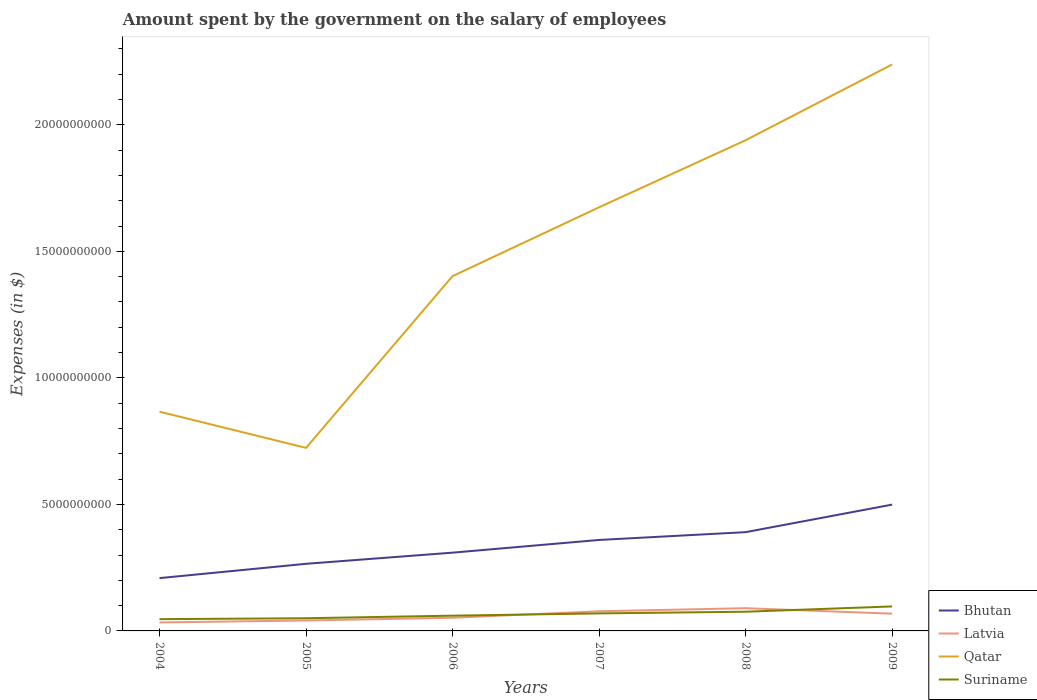Does the line corresponding to Bhutan intersect with the line corresponding to Latvia?
Offer a terse response. No. Is the number of lines equal to the number of legend labels?
Keep it short and to the point. Yes. Across all years, what is the maximum amount spent on the salary of employees by the government in Qatar?
Keep it short and to the point. 7.23e+09. In which year was the amount spent on the salary of employees by the government in Qatar maximum?
Provide a short and direct response. 2005. What is the total amount spent on the salary of employees by the government in Qatar in the graph?
Offer a very short reply. -6.79e+09. What is the difference between the highest and the second highest amount spent on the salary of employees by the government in Bhutan?
Ensure brevity in your answer.  2.90e+09. What is the difference between the highest and the lowest amount spent on the salary of employees by the government in Suriname?
Offer a very short reply. 3. What is the difference between two consecutive major ticks on the Y-axis?
Give a very brief answer. 5.00e+09. Are the values on the major ticks of Y-axis written in scientific E-notation?
Give a very brief answer. No. Does the graph contain grids?
Provide a short and direct response. No. Where does the legend appear in the graph?
Offer a terse response. Bottom right. How many legend labels are there?
Your answer should be very brief. 4. How are the legend labels stacked?
Provide a short and direct response. Vertical. What is the title of the graph?
Ensure brevity in your answer.  Amount spent by the government on the salary of employees. Does "Iceland" appear as one of the legend labels in the graph?
Offer a terse response. No. What is the label or title of the Y-axis?
Offer a very short reply. Expenses (in $). What is the Expenses (in $) of Bhutan in 2004?
Keep it short and to the point. 2.09e+09. What is the Expenses (in $) in Latvia in 2004?
Provide a succinct answer. 3.35e+08. What is the Expenses (in $) of Qatar in 2004?
Give a very brief answer. 8.66e+09. What is the Expenses (in $) of Suriname in 2004?
Ensure brevity in your answer.  4.65e+08. What is the Expenses (in $) of Bhutan in 2005?
Make the answer very short. 2.65e+09. What is the Expenses (in $) in Latvia in 2005?
Provide a short and direct response. 4.13e+08. What is the Expenses (in $) of Qatar in 2005?
Offer a very short reply. 7.23e+09. What is the Expenses (in $) of Suriname in 2005?
Make the answer very short. 5.02e+08. What is the Expenses (in $) of Bhutan in 2006?
Keep it short and to the point. 3.09e+09. What is the Expenses (in $) of Latvia in 2006?
Ensure brevity in your answer.  5.21e+08. What is the Expenses (in $) of Qatar in 2006?
Make the answer very short. 1.40e+1. What is the Expenses (in $) of Suriname in 2006?
Your response must be concise. 6.03e+08. What is the Expenses (in $) of Bhutan in 2007?
Your answer should be very brief. 3.60e+09. What is the Expenses (in $) in Latvia in 2007?
Your answer should be compact. 7.76e+08. What is the Expenses (in $) of Qatar in 2007?
Your answer should be very brief. 1.67e+1. What is the Expenses (in $) of Suriname in 2007?
Your response must be concise. 6.92e+08. What is the Expenses (in $) in Bhutan in 2008?
Your response must be concise. 3.90e+09. What is the Expenses (in $) of Latvia in 2008?
Your answer should be compact. 8.98e+08. What is the Expenses (in $) in Qatar in 2008?
Provide a succinct answer. 1.94e+1. What is the Expenses (in $) in Suriname in 2008?
Offer a very short reply. 7.59e+08. What is the Expenses (in $) in Bhutan in 2009?
Provide a short and direct response. 4.99e+09. What is the Expenses (in $) in Latvia in 2009?
Your answer should be compact. 6.81e+08. What is the Expenses (in $) of Qatar in 2009?
Offer a terse response. 2.24e+1. What is the Expenses (in $) of Suriname in 2009?
Give a very brief answer. 9.68e+08. Across all years, what is the maximum Expenses (in $) of Bhutan?
Provide a short and direct response. 4.99e+09. Across all years, what is the maximum Expenses (in $) in Latvia?
Give a very brief answer. 8.98e+08. Across all years, what is the maximum Expenses (in $) of Qatar?
Offer a very short reply. 2.24e+1. Across all years, what is the maximum Expenses (in $) of Suriname?
Offer a terse response. 9.68e+08. Across all years, what is the minimum Expenses (in $) of Bhutan?
Give a very brief answer. 2.09e+09. Across all years, what is the minimum Expenses (in $) of Latvia?
Keep it short and to the point. 3.35e+08. Across all years, what is the minimum Expenses (in $) in Qatar?
Offer a terse response. 7.23e+09. Across all years, what is the minimum Expenses (in $) of Suriname?
Ensure brevity in your answer.  4.65e+08. What is the total Expenses (in $) of Bhutan in the graph?
Offer a terse response. 2.03e+1. What is the total Expenses (in $) of Latvia in the graph?
Make the answer very short. 3.63e+09. What is the total Expenses (in $) in Qatar in the graph?
Your response must be concise. 8.84e+1. What is the total Expenses (in $) of Suriname in the graph?
Provide a succinct answer. 3.99e+09. What is the difference between the Expenses (in $) in Bhutan in 2004 and that in 2005?
Provide a short and direct response. -5.66e+08. What is the difference between the Expenses (in $) of Latvia in 2004 and that in 2005?
Ensure brevity in your answer.  -7.79e+07. What is the difference between the Expenses (in $) in Qatar in 2004 and that in 2005?
Offer a very short reply. 1.43e+09. What is the difference between the Expenses (in $) of Suriname in 2004 and that in 2005?
Your response must be concise. -3.64e+07. What is the difference between the Expenses (in $) of Bhutan in 2004 and that in 2006?
Your answer should be compact. -1.01e+09. What is the difference between the Expenses (in $) of Latvia in 2004 and that in 2006?
Make the answer very short. -1.86e+08. What is the difference between the Expenses (in $) of Qatar in 2004 and that in 2006?
Provide a succinct answer. -5.36e+09. What is the difference between the Expenses (in $) in Suriname in 2004 and that in 2006?
Your answer should be compact. -1.38e+08. What is the difference between the Expenses (in $) in Bhutan in 2004 and that in 2007?
Your answer should be compact. -1.51e+09. What is the difference between the Expenses (in $) in Latvia in 2004 and that in 2007?
Provide a succinct answer. -4.41e+08. What is the difference between the Expenses (in $) of Qatar in 2004 and that in 2007?
Provide a short and direct response. -8.08e+09. What is the difference between the Expenses (in $) in Suriname in 2004 and that in 2007?
Your response must be concise. -2.27e+08. What is the difference between the Expenses (in $) of Bhutan in 2004 and that in 2008?
Keep it short and to the point. -1.82e+09. What is the difference between the Expenses (in $) of Latvia in 2004 and that in 2008?
Make the answer very short. -5.63e+08. What is the difference between the Expenses (in $) in Qatar in 2004 and that in 2008?
Offer a very short reply. -1.07e+1. What is the difference between the Expenses (in $) in Suriname in 2004 and that in 2008?
Keep it short and to the point. -2.93e+08. What is the difference between the Expenses (in $) of Bhutan in 2004 and that in 2009?
Offer a terse response. -2.90e+09. What is the difference between the Expenses (in $) in Latvia in 2004 and that in 2009?
Offer a terse response. -3.46e+08. What is the difference between the Expenses (in $) in Qatar in 2004 and that in 2009?
Your answer should be compact. -1.37e+1. What is the difference between the Expenses (in $) of Suriname in 2004 and that in 2009?
Offer a very short reply. -5.02e+08. What is the difference between the Expenses (in $) in Bhutan in 2005 and that in 2006?
Provide a short and direct response. -4.40e+08. What is the difference between the Expenses (in $) of Latvia in 2005 and that in 2006?
Your response must be concise. -1.08e+08. What is the difference between the Expenses (in $) of Qatar in 2005 and that in 2006?
Your response must be concise. -6.79e+09. What is the difference between the Expenses (in $) of Suriname in 2005 and that in 2006?
Your answer should be compact. -1.01e+08. What is the difference between the Expenses (in $) in Bhutan in 2005 and that in 2007?
Your response must be concise. -9.43e+08. What is the difference between the Expenses (in $) of Latvia in 2005 and that in 2007?
Offer a very short reply. -3.63e+08. What is the difference between the Expenses (in $) of Qatar in 2005 and that in 2007?
Your answer should be compact. -9.51e+09. What is the difference between the Expenses (in $) in Suriname in 2005 and that in 2007?
Keep it short and to the point. -1.91e+08. What is the difference between the Expenses (in $) in Bhutan in 2005 and that in 2008?
Offer a terse response. -1.25e+09. What is the difference between the Expenses (in $) of Latvia in 2005 and that in 2008?
Give a very brief answer. -4.85e+08. What is the difference between the Expenses (in $) in Qatar in 2005 and that in 2008?
Offer a terse response. -1.22e+1. What is the difference between the Expenses (in $) of Suriname in 2005 and that in 2008?
Keep it short and to the point. -2.57e+08. What is the difference between the Expenses (in $) of Bhutan in 2005 and that in 2009?
Provide a short and direct response. -2.34e+09. What is the difference between the Expenses (in $) of Latvia in 2005 and that in 2009?
Keep it short and to the point. -2.68e+08. What is the difference between the Expenses (in $) in Qatar in 2005 and that in 2009?
Your answer should be compact. -1.52e+1. What is the difference between the Expenses (in $) in Suriname in 2005 and that in 2009?
Offer a terse response. -4.66e+08. What is the difference between the Expenses (in $) of Bhutan in 2006 and that in 2007?
Your response must be concise. -5.02e+08. What is the difference between the Expenses (in $) of Latvia in 2006 and that in 2007?
Offer a very short reply. -2.56e+08. What is the difference between the Expenses (in $) of Qatar in 2006 and that in 2007?
Your answer should be compact. -2.72e+09. What is the difference between the Expenses (in $) in Suriname in 2006 and that in 2007?
Ensure brevity in your answer.  -8.94e+07. What is the difference between the Expenses (in $) of Bhutan in 2006 and that in 2008?
Keep it short and to the point. -8.10e+08. What is the difference between the Expenses (in $) of Latvia in 2006 and that in 2008?
Ensure brevity in your answer.  -3.77e+08. What is the difference between the Expenses (in $) of Qatar in 2006 and that in 2008?
Offer a terse response. -5.37e+09. What is the difference between the Expenses (in $) of Suriname in 2006 and that in 2008?
Make the answer very short. -1.56e+08. What is the difference between the Expenses (in $) of Bhutan in 2006 and that in 2009?
Provide a succinct answer. -1.90e+09. What is the difference between the Expenses (in $) of Latvia in 2006 and that in 2009?
Your answer should be compact. -1.60e+08. What is the difference between the Expenses (in $) in Qatar in 2006 and that in 2009?
Your answer should be very brief. -8.36e+09. What is the difference between the Expenses (in $) in Suriname in 2006 and that in 2009?
Offer a very short reply. -3.65e+08. What is the difference between the Expenses (in $) of Bhutan in 2007 and that in 2008?
Offer a very short reply. -3.08e+08. What is the difference between the Expenses (in $) in Latvia in 2007 and that in 2008?
Your response must be concise. -1.22e+08. What is the difference between the Expenses (in $) in Qatar in 2007 and that in 2008?
Your response must be concise. -2.65e+09. What is the difference between the Expenses (in $) of Suriname in 2007 and that in 2008?
Provide a succinct answer. -6.61e+07. What is the difference between the Expenses (in $) in Bhutan in 2007 and that in 2009?
Make the answer very short. -1.40e+09. What is the difference between the Expenses (in $) in Latvia in 2007 and that in 2009?
Give a very brief answer. 9.54e+07. What is the difference between the Expenses (in $) of Qatar in 2007 and that in 2009?
Make the answer very short. -5.64e+09. What is the difference between the Expenses (in $) of Suriname in 2007 and that in 2009?
Your response must be concise. -2.75e+08. What is the difference between the Expenses (in $) of Bhutan in 2008 and that in 2009?
Your answer should be compact. -1.09e+09. What is the difference between the Expenses (in $) in Latvia in 2008 and that in 2009?
Keep it short and to the point. 2.17e+08. What is the difference between the Expenses (in $) in Qatar in 2008 and that in 2009?
Keep it short and to the point. -2.99e+09. What is the difference between the Expenses (in $) of Suriname in 2008 and that in 2009?
Your answer should be very brief. -2.09e+08. What is the difference between the Expenses (in $) of Bhutan in 2004 and the Expenses (in $) of Latvia in 2005?
Your response must be concise. 1.67e+09. What is the difference between the Expenses (in $) of Bhutan in 2004 and the Expenses (in $) of Qatar in 2005?
Keep it short and to the point. -5.15e+09. What is the difference between the Expenses (in $) of Bhutan in 2004 and the Expenses (in $) of Suriname in 2005?
Your answer should be very brief. 1.59e+09. What is the difference between the Expenses (in $) in Latvia in 2004 and the Expenses (in $) in Qatar in 2005?
Keep it short and to the point. -6.90e+09. What is the difference between the Expenses (in $) in Latvia in 2004 and the Expenses (in $) in Suriname in 2005?
Offer a terse response. -1.66e+08. What is the difference between the Expenses (in $) in Qatar in 2004 and the Expenses (in $) in Suriname in 2005?
Provide a short and direct response. 8.16e+09. What is the difference between the Expenses (in $) of Bhutan in 2004 and the Expenses (in $) of Latvia in 2006?
Make the answer very short. 1.57e+09. What is the difference between the Expenses (in $) in Bhutan in 2004 and the Expenses (in $) in Qatar in 2006?
Your answer should be very brief. -1.19e+1. What is the difference between the Expenses (in $) of Bhutan in 2004 and the Expenses (in $) of Suriname in 2006?
Your response must be concise. 1.48e+09. What is the difference between the Expenses (in $) in Latvia in 2004 and the Expenses (in $) in Qatar in 2006?
Offer a terse response. -1.37e+1. What is the difference between the Expenses (in $) of Latvia in 2004 and the Expenses (in $) of Suriname in 2006?
Provide a succinct answer. -2.68e+08. What is the difference between the Expenses (in $) in Qatar in 2004 and the Expenses (in $) in Suriname in 2006?
Your response must be concise. 8.06e+09. What is the difference between the Expenses (in $) in Bhutan in 2004 and the Expenses (in $) in Latvia in 2007?
Provide a succinct answer. 1.31e+09. What is the difference between the Expenses (in $) in Bhutan in 2004 and the Expenses (in $) in Qatar in 2007?
Make the answer very short. -1.47e+1. What is the difference between the Expenses (in $) in Bhutan in 2004 and the Expenses (in $) in Suriname in 2007?
Provide a succinct answer. 1.39e+09. What is the difference between the Expenses (in $) in Latvia in 2004 and the Expenses (in $) in Qatar in 2007?
Ensure brevity in your answer.  -1.64e+1. What is the difference between the Expenses (in $) of Latvia in 2004 and the Expenses (in $) of Suriname in 2007?
Your answer should be very brief. -3.57e+08. What is the difference between the Expenses (in $) in Qatar in 2004 and the Expenses (in $) in Suriname in 2007?
Provide a succinct answer. 7.97e+09. What is the difference between the Expenses (in $) of Bhutan in 2004 and the Expenses (in $) of Latvia in 2008?
Your answer should be compact. 1.19e+09. What is the difference between the Expenses (in $) of Bhutan in 2004 and the Expenses (in $) of Qatar in 2008?
Keep it short and to the point. -1.73e+1. What is the difference between the Expenses (in $) in Bhutan in 2004 and the Expenses (in $) in Suriname in 2008?
Provide a succinct answer. 1.33e+09. What is the difference between the Expenses (in $) of Latvia in 2004 and the Expenses (in $) of Qatar in 2008?
Offer a terse response. -1.91e+1. What is the difference between the Expenses (in $) of Latvia in 2004 and the Expenses (in $) of Suriname in 2008?
Your answer should be compact. -4.23e+08. What is the difference between the Expenses (in $) of Qatar in 2004 and the Expenses (in $) of Suriname in 2008?
Provide a short and direct response. 7.90e+09. What is the difference between the Expenses (in $) of Bhutan in 2004 and the Expenses (in $) of Latvia in 2009?
Offer a terse response. 1.41e+09. What is the difference between the Expenses (in $) in Bhutan in 2004 and the Expenses (in $) in Qatar in 2009?
Offer a very short reply. -2.03e+1. What is the difference between the Expenses (in $) in Bhutan in 2004 and the Expenses (in $) in Suriname in 2009?
Keep it short and to the point. 1.12e+09. What is the difference between the Expenses (in $) in Latvia in 2004 and the Expenses (in $) in Qatar in 2009?
Give a very brief answer. -2.20e+1. What is the difference between the Expenses (in $) in Latvia in 2004 and the Expenses (in $) in Suriname in 2009?
Give a very brief answer. -6.32e+08. What is the difference between the Expenses (in $) in Qatar in 2004 and the Expenses (in $) in Suriname in 2009?
Your answer should be compact. 7.70e+09. What is the difference between the Expenses (in $) in Bhutan in 2005 and the Expenses (in $) in Latvia in 2006?
Offer a very short reply. 2.13e+09. What is the difference between the Expenses (in $) of Bhutan in 2005 and the Expenses (in $) of Qatar in 2006?
Keep it short and to the point. -1.14e+1. What is the difference between the Expenses (in $) in Bhutan in 2005 and the Expenses (in $) in Suriname in 2006?
Keep it short and to the point. 2.05e+09. What is the difference between the Expenses (in $) of Latvia in 2005 and the Expenses (in $) of Qatar in 2006?
Offer a terse response. -1.36e+1. What is the difference between the Expenses (in $) in Latvia in 2005 and the Expenses (in $) in Suriname in 2006?
Your response must be concise. -1.90e+08. What is the difference between the Expenses (in $) of Qatar in 2005 and the Expenses (in $) of Suriname in 2006?
Your answer should be compact. 6.63e+09. What is the difference between the Expenses (in $) in Bhutan in 2005 and the Expenses (in $) in Latvia in 2007?
Provide a short and direct response. 1.88e+09. What is the difference between the Expenses (in $) of Bhutan in 2005 and the Expenses (in $) of Qatar in 2007?
Your response must be concise. -1.41e+1. What is the difference between the Expenses (in $) in Bhutan in 2005 and the Expenses (in $) in Suriname in 2007?
Offer a very short reply. 1.96e+09. What is the difference between the Expenses (in $) of Latvia in 2005 and the Expenses (in $) of Qatar in 2007?
Provide a short and direct response. -1.63e+1. What is the difference between the Expenses (in $) in Latvia in 2005 and the Expenses (in $) in Suriname in 2007?
Your response must be concise. -2.79e+08. What is the difference between the Expenses (in $) of Qatar in 2005 and the Expenses (in $) of Suriname in 2007?
Your answer should be very brief. 6.54e+09. What is the difference between the Expenses (in $) of Bhutan in 2005 and the Expenses (in $) of Latvia in 2008?
Your response must be concise. 1.75e+09. What is the difference between the Expenses (in $) of Bhutan in 2005 and the Expenses (in $) of Qatar in 2008?
Your answer should be compact. -1.67e+1. What is the difference between the Expenses (in $) in Bhutan in 2005 and the Expenses (in $) in Suriname in 2008?
Make the answer very short. 1.89e+09. What is the difference between the Expenses (in $) of Latvia in 2005 and the Expenses (in $) of Qatar in 2008?
Ensure brevity in your answer.  -1.90e+1. What is the difference between the Expenses (in $) in Latvia in 2005 and the Expenses (in $) in Suriname in 2008?
Your answer should be compact. -3.45e+08. What is the difference between the Expenses (in $) in Qatar in 2005 and the Expenses (in $) in Suriname in 2008?
Provide a succinct answer. 6.47e+09. What is the difference between the Expenses (in $) of Bhutan in 2005 and the Expenses (in $) of Latvia in 2009?
Offer a very short reply. 1.97e+09. What is the difference between the Expenses (in $) in Bhutan in 2005 and the Expenses (in $) in Qatar in 2009?
Provide a short and direct response. -1.97e+1. What is the difference between the Expenses (in $) of Bhutan in 2005 and the Expenses (in $) of Suriname in 2009?
Provide a short and direct response. 1.68e+09. What is the difference between the Expenses (in $) in Latvia in 2005 and the Expenses (in $) in Qatar in 2009?
Your answer should be compact. -2.20e+1. What is the difference between the Expenses (in $) of Latvia in 2005 and the Expenses (in $) of Suriname in 2009?
Offer a terse response. -5.54e+08. What is the difference between the Expenses (in $) in Qatar in 2005 and the Expenses (in $) in Suriname in 2009?
Make the answer very short. 6.27e+09. What is the difference between the Expenses (in $) of Bhutan in 2006 and the Expenses (in $) of Latvia in 2007?
Your response must be concise. 2.32e+09. What is the difference between the Expenses (in $) in Bhutan in 2006 and the Expenses (in $) in Qatar in 2007?
Your response must be concise. -1.36e+1. What is the difference between the Expenses (in $) in Bhutan in 2006 and the Expenses (in $) in Suriname in 2007?
Ensure brevity in your answer.  2.40e+09. What is the difference between the Expenses (in $) in Latvia in 2006 and the Expenses (in $) in Qatar in 2007?
Give a very brief answer. -1.62e+1. What is the difference between the Expenses (in $) of Latvia in 2006 and the Expenses (in $) of Suriname in 2007?
Keep it short and to the point. -1.72e+08. What is the difference between the Expenses (in $) in Qatar in 2006 and the Expenses (in $) in Suriname in 2007?
Offer a terse response. 1.33e+1. What is the difference between the Expenses (in $) in Bhutan in 2006 and the Expenses (in $) in Latvia in 2008?
Ensure brevity in your answer.  2.19e+09. What is the difference between the Expenses (in $) of Bhutan in 2006 and the Expenses (in $) of Qatar in 2008?
Provide a succinct answer. -1.63e+1. What is the difference between the Expenses (in $) in Bhutan in 2006 and the Expenses (in $) in Suriname in 2008?
Give a very brief answer. 2.33e+09. What is the difference between the Expenses (in $) in Latvia in 2006 and the Expenses (in $) in Qatar in 2008?
Offer a very short reply. -1.89e+1. What is the difference between the Expenses (in $) of Latvia in 2006 and the Expenses (in $) of Suriname in 2008?
Ensure brevity in your answer.  -2.38e+08. What is the difference between the Expenses (in $) of Qatar in 2006 and the Expenses (in $) of Suriname in 2008?
Offer a very short reply. 1.33e+1. What is the difference between the Expenses (in $) in Bhutan in 2006 and the Expenses (in $) in Latvia in 2009?
Ensure brevity in your answer.  2.41e+09. What is the difference between the Expenses (in $) of Bhutan in 2006 and the Expenses (in $) of Qatar in 2009?
Offer a very short reply. -1.93e+1. What is the difference between the Expenses (in $) in Bhutan in 2006 and the Expenses (in $) in Suriname in 2009?
Keep it short and to the point. 2.13e+09. What is the difference between the Expenses (in $) of Latvia in 2006 and the Expenses (in $) of Qatar in 2009?
Provide a short and direct response. -2.19e+1. What is the difference between the Expenses (in $) in Latvia in 2006 and the Expenses (in $) in Suriname in 2009?
Provide a short and direct response. -4.47e+08. What is the difference between the Expenses (in $) of Qatar in 2006 and the Expenses (in $) of Suriname in 2009?
Give a very brief answer. 1.31e+1. What is the difference between the Expenses (in $) of Bhutan in 2007 and the Expenses (in $) of Latvia in 2008?
Provide a succinct answer. 2.70e+09. What is the difference between the Expenses (in $) of Bhutan in 2007 and the Expenses (in $) of Qatar in 2008?
Offer a very short reply. -1.58e+1. What is the difference between the Expenses (in $) in Bhutan in 2007 and the Expenses (in $) in Suriname in 2008?
Your answer should be compact. 2.84e+09. What is the difference between the Expenses (in $) of Latvia in 2007 and the Expenses (in $) of Qatar in 2008?
Offer a terse response. -1.86e+1. What is the difference between the Expenses (in $) in Latvia in 2007 and the Expenses (in $) in Suriname in 2008?
Keep it short and to the point. 1.80e+07. What is the difference between the Expenses (in $) in Qatar in 2007 and the Expenses (in $) in Suriname in 2008?
Offer a terse response. 1.60e+1. What is the difference between the Expenses (in $) in Bhutan in 2007 and the Expenses (in $) in Latvia in 2009?
Your answer should be compact. 2.91e+09. What is the difference between the Expenses (in $) of Bhutan in 2007 and the Expenses (in $) of Qatar in 2009?
Your response must be concise. -1.88e+1. What is the difference between the Expenses (in $) of Bhutan in 2007 and the Expenses (in $) of Suriname in 2009?
Ensure brevity in your answer.  2.63e+09. What is the difference between the Expenses (in $) in Latvia in 2007 and the Expenses (in $) in Qatar in 2009?
Your answer should be compact. -2.16e+1. What is the difference between the Expenses (in $) in Latvia in 2007 and the Expenses (in $) in Suriname in 2009?
Ensure brevity in your answer.  -1.91e+08. What is the difference between the Expenses (in $) of Qatar in 2007 and the Expenses (in $) of Suriname in 2009?
Your answer should be very brief. 1.58e+1. What is the difference between the Expenses (in $) in Bhutan in 2008 and the Expenses (in $) in Latvia in 2009?
Offer a very short reply. 3.22e+09. What is the difference between the Expenses (in $) in Bhutan in 2008 and the Expenses (in $) in Qatar in 2009?
Give a very brief answer. -1.85e+1. What is the difference between the Expenses (in $) in Bhutan in 2008 and the Expenses (in $) in Suriname in 2009?
Your response must be concise. 2.94e+09. What is the difference between the Expenses (in $) of Latvia in 2008 and the Expenses (in $) of Qatar in 2009?
Offer a very short reply. -2.15e+1. What is the difference between the Expenses (in $) of Latvia in 2008 and the Expenses (in $) of Suriname in 2009?
Offer a terse response. -6.96e+07. What is the difference between the Expenses (in $) of Qatar in 2008 and the Expenses (in $) of Suriname in 2009?
Give a very brief answer. 1.84e+1. What is the average Expenses (in $) of Bhutan per year?
Your answer should be compact. 3.39e+09. What is the average Expenses (in $) of Latvia per year?
Provide a succinct answer. 6.04e+08. What is the average Expenses (in $) of Qatar per year?
Your answer should be compact. 1.47e+1. What is the average Expenses (in $) in Suriname per year?
Provide a succinct answer. 6.65e+08. In the year 2004, what is the difference between the Expenses (in $) in Bhutan and Expenses (in $) in Latvia?
Offer a very short reply. 1.75e+09. In the year 2004, what is the difference between the Expenses (in $) in Bhutan and Expenses (in $) in Qatar?
Your answer should be very brief. -6.58e+09. In the year 2004, what is the difference between the Expenses (in $) of Bhutan and Expenses (in $) of Suriname?
Your answer should be compact. 1.62e+09. In the year 2004, what is the difference between the Expenses (in $) in Latvia and Expenses (in $) in Qatar?
Give a very brief answer. -8.33e+09. In the year 2004, what is the difference between the Expenses (in $) of Latvia and Expenses (in $) of Suriname?
Make the answer very short. -1.30e+08. In the year 2004, what is the difference between the Expenses (in $) in Qatar and Expenses (in $) in Suriname?
Offer a very short reply. 8.20e+09. In the year 2005, what is the difference between the Expenses (in $) of Bhutan and Expenses (in $) of Latvia?
Provide a short and direct response. 2.24e+09. In the year 2005, what is the difference between the Expenses (in $) of Bhutan and Expenses (in $) of Qatar?
Your response must be concise. -4.58e+09. In the year 2005, what is the difference between the Expenses (in $) in Bhutan and Expenses (in $) in Suriname?
Give a very brief answer. 2.15e+09. In the year 2005, what is the difference between the Expenses (in $) in Latvia and Expenses (in $) in Qatar?
Provide a succinct answer. -6.82e+09. In the year 2005, what is the difference between the Expenses (in $) in Latvia and Expenses (in $) in Suriname?
Offer a very short reply. -8.83e+07. In the year 2005, what is the difference between the Expenses (in $) in Qatar and Expenses (in $) in Suriname?
Give a very brief answer. 6.73e+09. In the year 2006, what is the difference between the Expenses (in $) of Bhutan and Expenses (in $) of Latvia?
Your answer should be compact. 2.57e+09. In the year 2006, what is the difference between the Expenses (in $) of Bhutan and Expenses (in $) of Qatar?
Offer a terse response. -1.09e+1. In the year 2006, what is the difference between the Expenses (in $) in Bhutan and Expenses (in $) in Suriname?
Give a very brief answer. 2.49e+09. In the year 2006, what is the difference between the Expenses (in $) of Latvia and Expenses (in $) of Qatar?
Provide a short and direct response. -1.35e+1. In the year 2006, what is the difference between the Expenses (in $) of Latvia and Expenses (in $) of Suriname?
Your answer should be very brief. -8.21e+07. In the year 2006, what is the difference between the Expenses (in $) of Qatar and Expenses (in $) of Suriname?
Provide a short and direct response. 1.34e+1. In the year 2007, what is the difference between the Expenses (in $) of Bhutan and Expenses (in $) of Latvia?
Ensure brevity in your answer.  2.82e+09. In the year 2007, what is the difference between the Expenses (in $) of Bhutan and Expenses (in $) of Qatar?
Keep it short and to the point. -1.31e+1. In the year 2007, what is the difference between the Expenses (in $) in Bhutan and Expenses (in $) in Suriname?
Provide a succinct answer. 2.90e+09. In the year 2007, what is the difference between the Expenses (in $) in Latvia and Expenses (in $) in Qatar?
Provide a short and direct response. -1.60e+1. In the year 2007, what is the difference between the Expenses (in $) in Latvia and Expenses (in $) in Suriname?
Your answer should be very brief. 8.41e+07. In the year 2007, what is the difference between the Expenses (in $) of Qatar and Expenses (in $) of Suriname?
Provide a short and direct response. 1.60e+1. In the year 2008, what is the difference between the Expenses (in $) of Bhutan and Expenses (in $) of Latvia?
Make the answer very short. 3.01e+09. In the year 2008, what is the difference between the Expenses (in $) of Bhutan and Expenses (in $) of Qatar?
Provide a succinct answer. -1.55e+1. In the year 2008, what is the difference between the Expenses (in $) in Bhutan and Expenses (in $) in Suriname?
Offer a very short reply. 3.14e+09. In the year 2008, what is the difference between the Expenses (in $) in Latvia and Expenses (in $) in Qatar?
Ensure brevity in your answer.  -1.85e+1. In the year 2008, what is the difference between the Expenses (in $) in Latvia and Expenses (in $) in Suriname?
Keep it short and to the point. 1.39e+08. In the year 2008, what is the difference between the Expenses (in $) of Qatar and Expenses (in $) of Suriname?
Ensure brevity in your answer.  1.86e+1. In the year 2009, what is the difference between the Expenses (in $) of Bhutan and Expenses (in $) of Latvia?
Make the answer very short. 4.31e+09. In the year 2009, what is the difference between the Expenses (in $) in Bhutan and Expenses (in $) in Qatar?
Give a very brief answer. -1.74e+1. In the year 2009, what is the difference between the Expenses (in $) in Bhutan and Expenses (in $) in Suriname?
Keep it short and to the point. 4.02e+09. In the year 2009, what is the difference between the Expenses (in $) in Latvia and Expenses (in $) in Qatar?
Give a very brief answer. -2.17e+1. In the year 2009, what is the difference between the Expenses (in $) of Latvia and Expenses (in $) of Suriname?
Offer a terse response. -2.86e+08. In the year 2009, what is the difference between the Expenses (in $) of Qatar and Expenses (in $) of Suriname?
Offer a very short reply. 2.14e+1. What is the ratio of the Expenses (in $) of Bhutan in 2004 to that in 2005?
Offer a very short reply. 0.79. What is the ratio of the Expenses (in $) of Latvia in 2004 to that in 2005?
Offer a terse response. 0.81. What is the ratio of the Expenses (in $) of Qatar in 2004 to that in 2005?
Offer a very short reply. 1.2. What is the ratio of the Expenses (in $) in Suriname in 2004 to that in 2005?
Keep it short and to the point. 0.93. What is the ratio of the Expenses (in $) of Bhutan in 2004 to that in 2006?
Keep it short and to the point. 0.67. What is the ratio of the Expenses (in $) of Latvia in 2004 to that in 2006?
Offer a terse response. 0.64. What is the ratio of the Expenses (in $) in Qatar in 2004 to that in 2006?
Offer a terse response. 0.62. What is the ratio of the Expenses (in $) in Suriname in 2004 to that in 2006?
Offer a terse response. 0.77. What is the ratio of the Expenses (in $) in Bhutan in 2004 to that in 2007?
Provide a short and direct response. 0.58. What is the ratio of the Expenses (in $) in Latvia in 2004 to that in 2007?
Give a very brief answer. 0.43. What is the ratio of the Expenses (in $) in Qatar in 2004 to that in 2007?
Provide a succinct answer. 0.52. What is the ratio of the Expenses (in $) in Suriname in 2004 to that in 2007?
Provide a succinct answer. 0.67. What is the ratio of the Expenses (in $) of Bhutan in 2004 to that in 2008?
Provide a short and direct response. 0.53. What is the ratio of the Expenses (in $) in Latvia in 2004 to that in 2008?
Your answer should be compact. 0.37. What is the ratio of the Expenses (in $) of Qatar in 2004 to that in 2008?
Provide a short and direct response. 0.45. What is the ratio of the Expenses (in $) in Suriname in 2004 to that in 2008?
Keep it short and to the point. 0.61. What is the ratio of the Expenses (in $) in Bhutan in 2004 to that in 2009?
Offer a very short reply. 0.42. What is the ratio of the Expenses (in $) of Latvia in 2004 to that in 2009?
Ensure brevity in your answer.  0.49. What is the ratio of the Expenses (in $) in Qatar in 2004 to that in 2009?
Keep it short and to the point. 0.39. What is the ratio of the Expenses (in $) in Suriname in 2004 to that in 2009?
Your answer should be compact. 0.48. What is the ratio of the Expenses (in $) of Bhutan in 2005 to that in 2006?
Offer a terse response. 0.86. What is the ratio of the Expenses (in $) of Latvia in 2005 to that in 2006?
Give a very brief answer. 0.79. What is the ratio of the Expenses (in $) in Qatar in 2005 to that in 2006?
Your answer should be compact. 0.52. What is the ratio of the Expenses (in $) in Suriname in 2005 to that in 2006?
Provide a short and direct response. 0.83. What is the ratio of the Expenses (in $) of Bhutan in 2005 to that in 2007?
Your answer should be very brief. 0.74. What is the ratio of the Expenses (in $) of Latvia in 2005 to that in 2007?
Provide a short and direct response. 0.53. What is the ratio of the Expenses (in $) in Qatar in 2005 to that in 2007?
Your response must be concise. 0.43. What is the ratio of the Expenses (in $) in Suriname in 2005 to that in 2007?
Your answer should be very brief. 0.72. What is the ratio of the Expenses (in $) of Bhutan in 2005 to that in 2008?
Give a very brief answer. 0.68. What is the ratio of the Expenses (in $) in Latvia in 2005 to that in 2008?
Your answer should be very brief. 0.46. What is the ratio of the Expenses (in $) in Qatar in 2005 to that in 2008?
Offer a very short reply. 0.37. What is the ratio of the Expenses (in $) in Suriname in 2005 to that in 2008?
Ensure brevity in your answer.  0.66. What is the ratio of the Expenses (in $) in Bhutan in 2005 to that in 2009?
Give a very brief answer. 0.53. What is the ratio of the Expenses (in $) of Latvia in 2005 to that in 2009?
Offer a terse response. 0.61. What is the ratio of the Expenses (in $) of Qatar in 2005 to that in 2009?
Your answer should be compact. 0.32. What is the ratio of the Expenses (in $) in Suriname in 2005 to that in 2009?
Keep it short and to the point. 0.52. What is the ratio of the Expenses (in $) in Bhutan in 2006 to that in 2007?
Provide a succinct answer. 0.86. What is the ratio of the Expenses (in $) in Latvia in 2006 to that in 2007?
Ensure brevity in your answer.  0.67. What is the ratio of the Expenses (in $) in Qatar in 2006 to that in 2007?
Offer a very short reply. 0.84. What is the ratio of the Expenses (in $) of Suriname in 2006 to that in 2007?
Provide a succinct answer. 0.87. What is the ratio of the Expenses (in $) in Bhutan in 2006 to that in 2008?
Your response must be concise. 0.79. What is the ratio of the Expenses (in $) of Latvia in 2006 to that in 2008?
Your answer should be very brief. 0.58. What is the ratio of the Expenses (in $) of Qatar in 2006 to that in 2008?
Offer a terse response. 0.72. What is the ratio of the Expenses (in $) in Suriname in 2006 to that in 2008?
Provide a succinct answer. 0.8. What is the ratio of the Expenses (in $) in Bhutan in 2006 to that in 2009?
Keep it short and to the point. 0.62. What is the ratio of the Expenses (in $) in Latvia in 2006 to that in 2009?
Your answer should be very brief. 0.76. What is the ratio of the Expenses (in $) of Qatar in 2006 to that in 2009?
Ensure brevity in your answer.  0.63. What is the ratio of the Expenses (in $) in Suriname in 2006 to that in 2009?
Keep it short and to the point. 0.62. What is the ratio of the Expenses (in $) of Bhutan in 2007 to that in 2008?
Your response must be concise. 0.92. What is the ratio of the Expenses (in $) of Latvia in 2007 to that in 2008?
Make the answer very short. 0.86. What is the ratio of the Expenses (in $) of Qatar in 2007 to that in 2008?
Your answer should be very brief. 0.86. What is the ratio of the Expenses (in $) of Suriname in 2007 to that in 2008?
Make the answer very short. 0.91. What is the ratio of the Expenses (in $) in Bhutan in 2007 to that in 2009?
Keep it short and to the point. 0.72. What is the ratio of the Expenses (in $) in Latvia in 2007 to that in 2009?
Offer a very short reply. 1.14. What is the ratio of the Expenses (in $) in Qatar in 2007 to that in 2009?
Offer a very short reply. 0.75. What is the ratio of the Expenses (in $) in Suriname in 2007 to that in 2009?
Keep it short and to the point. 0.72. What is the ratio of the Expenses (in $) of Bhutan in 2008 to that in 2009?
Your answer should be very brief. 0.78. What is the ratio of the Expenses (in $) of Latvia in 2008 to that in 2009?
Your response must be concise. 1.32. What is the ratio of the Expenses (in $) of Qatar in 2008 to that in 2009?
Your response must be concise. 0.87. What is the ratio of the Expenses (in $) in Suriname in 2008 to that in 2009?
Provide a short and direct response. 0.78. What is the difference between the highest and the second highest Expenses (in $) of Bhutan?
Keep it short and to the point. 1.09e+09. What is the difference between the highest and the second highest Expenses (in $) of Latvia?
Give a very brief answer. 1.22e+08. What is the difference between the highest and the second highest Expenses (in $) in Qatar?
Make the answer very short. 2.99e+09. What is the difference between the highest and the second highest Expenses (in $) in Suriname?
Provide a short and direct response. 2.09e+08. What is the difference between the highest and the lowest Expenses (in $) in Bhutan?
Give a very brief answer. 2.90e+09. What is the difference between the highest and the lowest Expenses (in $) in Latvia?
Make the answer very short. 5.63e+08. What is the difference between the highest and the lowest Expenses (in $) of Qatar?
Give a very brief answer. 1.52e+1. What is the difference between the highest and the lowest Expenses (in $) of Suriname?
Provide a succinct answer. 5.02e+08. 